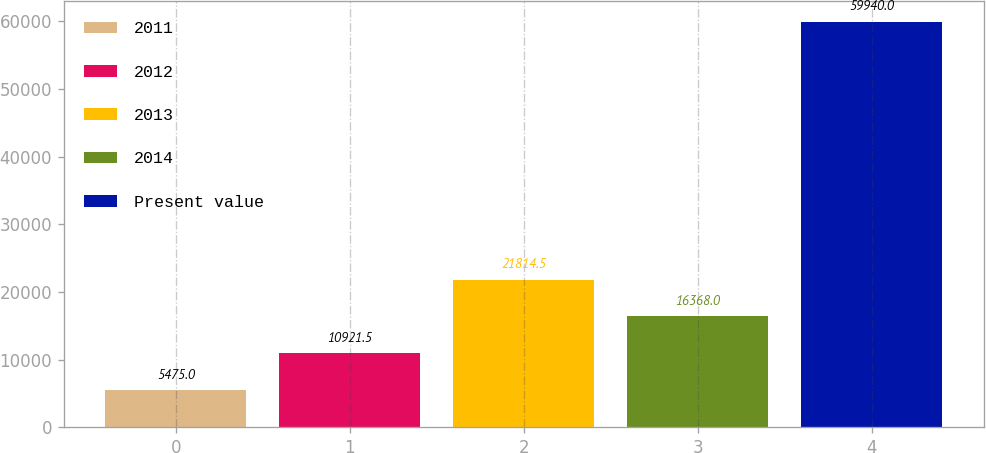Convert chart. <chart><loc_0><loc_0><loc_500><loc_500><bar_chart><fcel>2011<fcel>2012<fcel>2013<fcel>2014<fcel>Present value<nl><fcel>5475<fcel>10921.5<fcel>21814.5<fcel>16368<fcel>59940<nl></chart> 